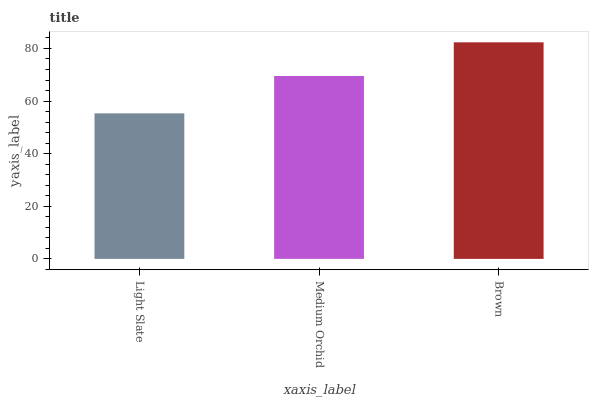Is Light Slate the minimum?
Answer yes or no. Yes. Is Brown the maximum?
Answer yes or no. Yes. Is Medium Orchid the minimum?
Answer yes or no. No. Is Medium Orchid the maximum?
Answer yes or no. No. Is Medium Orchid greater than Light Slate?
Answer yes or no. Yes. Is Light Slate less than Medium Orchid?
Answer yes or no. Yes. Is Light Slate greater than Medium Orchid?
Answer yes or no. No. Is Medium Orchid less than Light Slate?
Answer yes or no. No. Is Medium Orchid the high median?
Answer yes or no. Yes. Is Medium Orchid the low median?
Answer yes or no. Yes. Is Light Slate the high median?
Answer yes or no. No. Is Brown the low median?
Answer yes or no. No. 